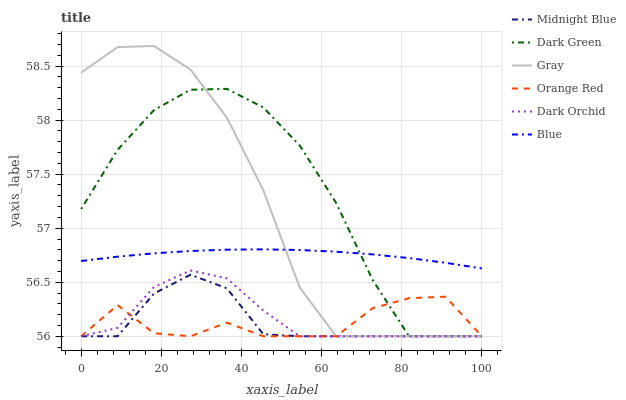Does Gray have the minimum area under the curve?
Answer yes or no. No. Does Gray have the maximum area under the curve?
Answer yes or no. No. Is Gray the smoothest?
Answer yes or no. No. Is Gray the roughest?
Answer yes or no. No. Does Midnight Blue have the highest value?
Answer yes or no. No. Is Orange Red less than Blue?
Answer yes or no. Yes. Is Blue greater than Midnight Blue?
Answer yes or no. Yes. Does Orange Red intersect Blue?
Answer yes or no. No. 